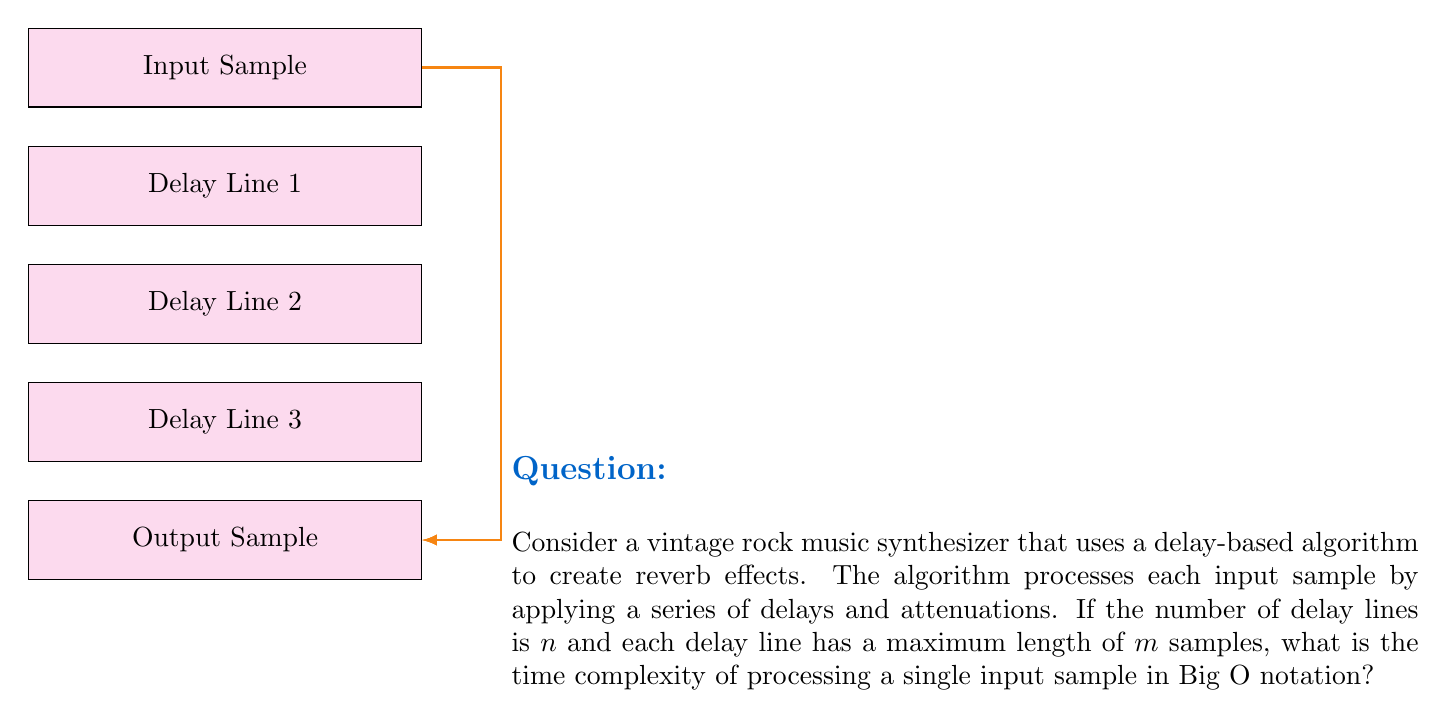Show me your answer to this math problem. Let's break down the problem and analyze the algorithm step-by-step:

1) For each input sample, the algorithm needs to process $n$ delay lines.

2) Each delay line can have up to $m$ samples, which means we need to perform operations on potentially all $m$ samples in each line.

3) The basic operations for each sample in a delay line typically include:
   - Reading the current value
   - Applying attenuation (multiplication)
   - Adding to the output

4) These operations are constant time, let's call their combined time $c$.

5) For each delay line, we perform these operations $m$ times in the worst case.

6) We do this for all $n$ delay lines.

7) Therefore, for each input sample, the total number of operations is:

   $$ n \times m \times c $$

8) In Big O notation, we ignore constant factors, so we can drop $c$.

9) This leaves us with a time complexity of $O(nm)$ for processing each input sample.

This analysis assumes that the number of delay lines ($n$) and the maximum delay length ($m$) are independent variables. In practice, they might be related, but without more specific information, we treat them as separate factors affecting the time complexity.
Answer: $O(nm)$ 